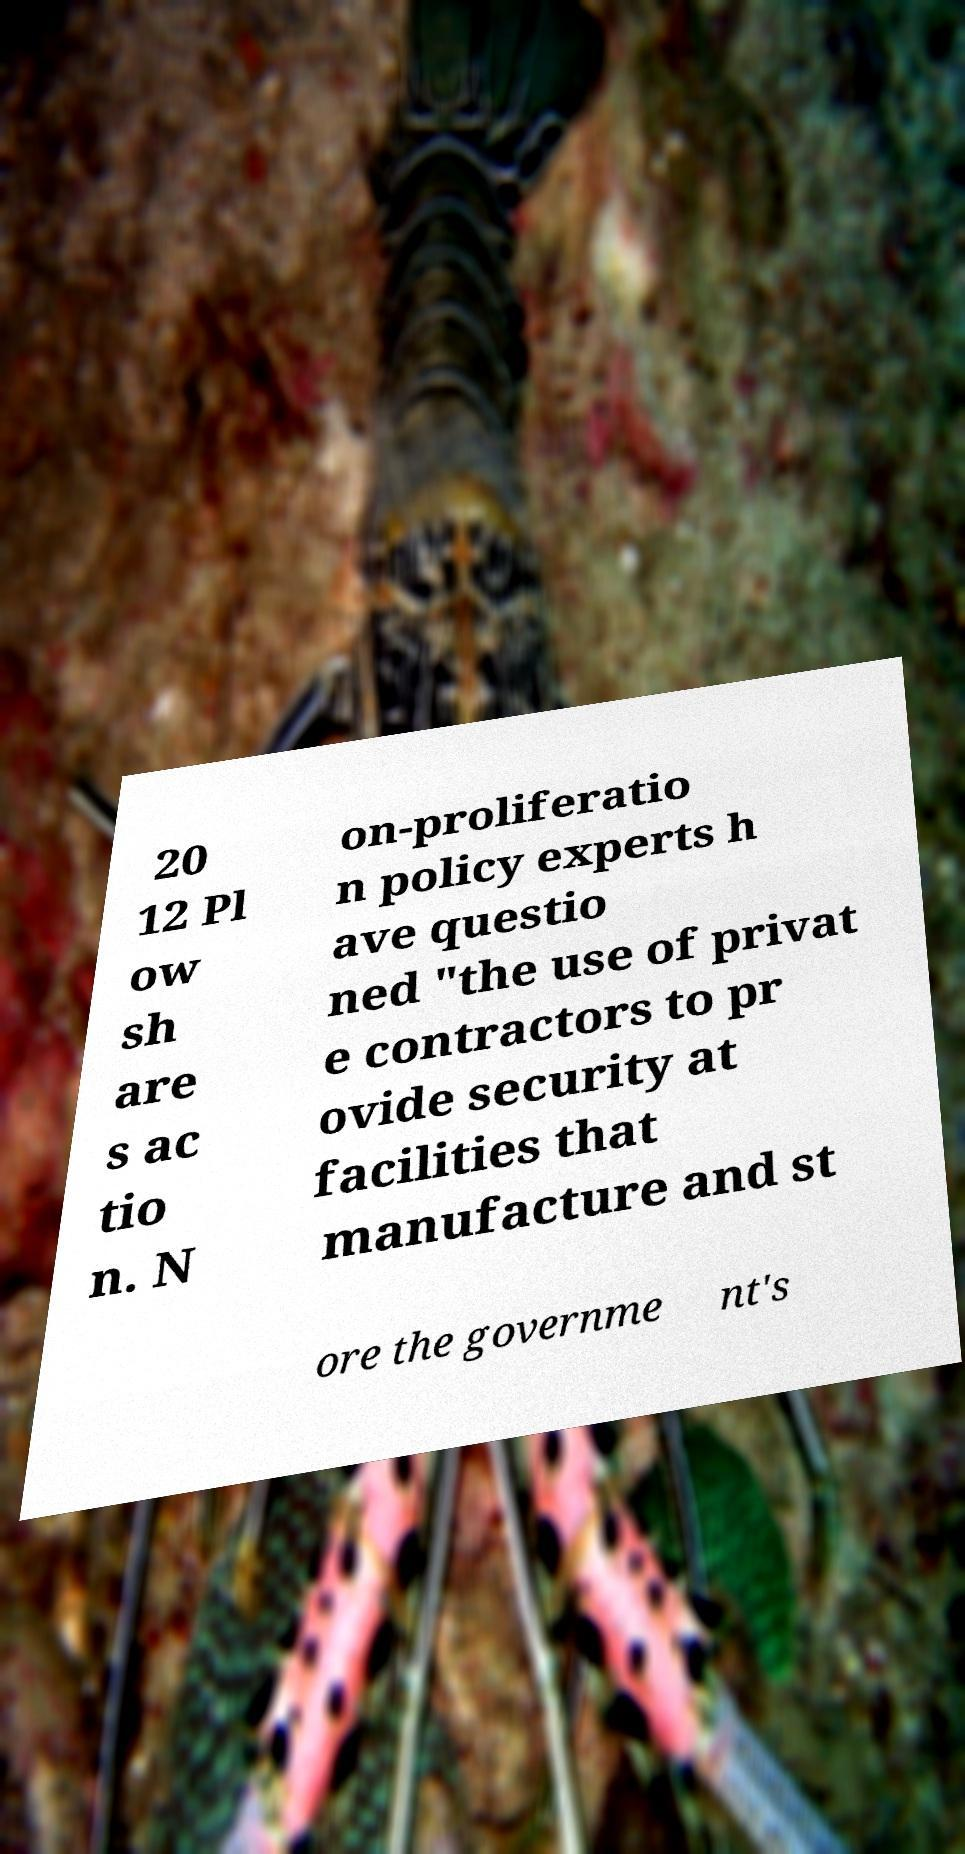Please identify and transcribe the text found in this image. 20 12 Pl ow sh are s ac tio n. N on-proliferatio n policy experts h ave questio ned "the use of privat e contractors to pr ovide security at facilities that manufacture and st ore the governme nt's 